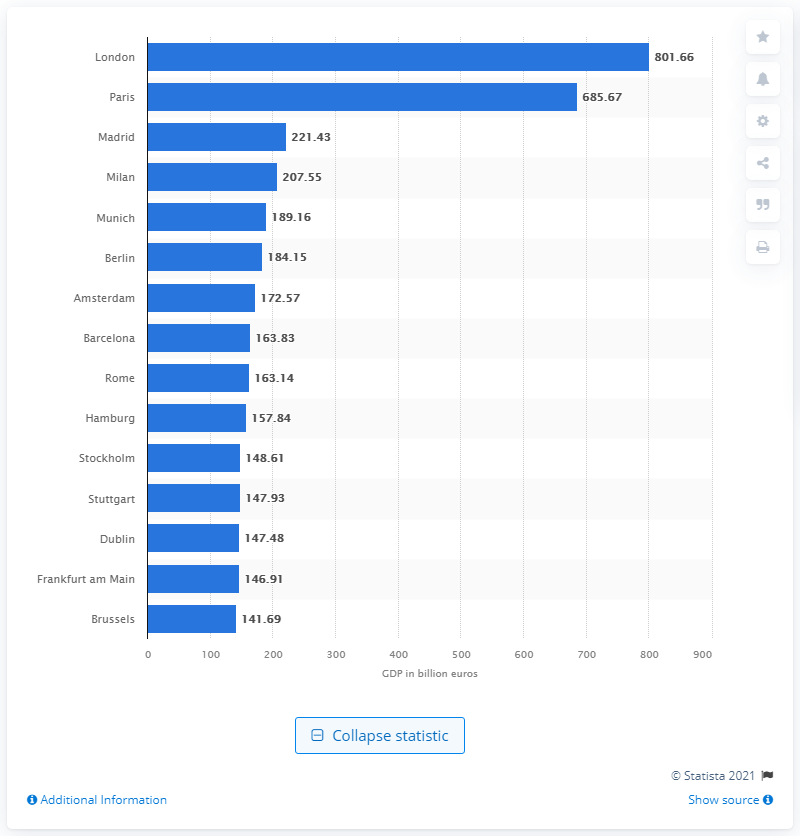Outline some significant characteristics in this image. The capital of France is Paris. In 2017/18, Milan's Gross Domestic Product (GDP) was 207.55. In the year 2017/18, London's gross domestic product (GDP) was 801.66 billion U.S. dollars. The capital of Spain in 2017/18 was Madrid. 